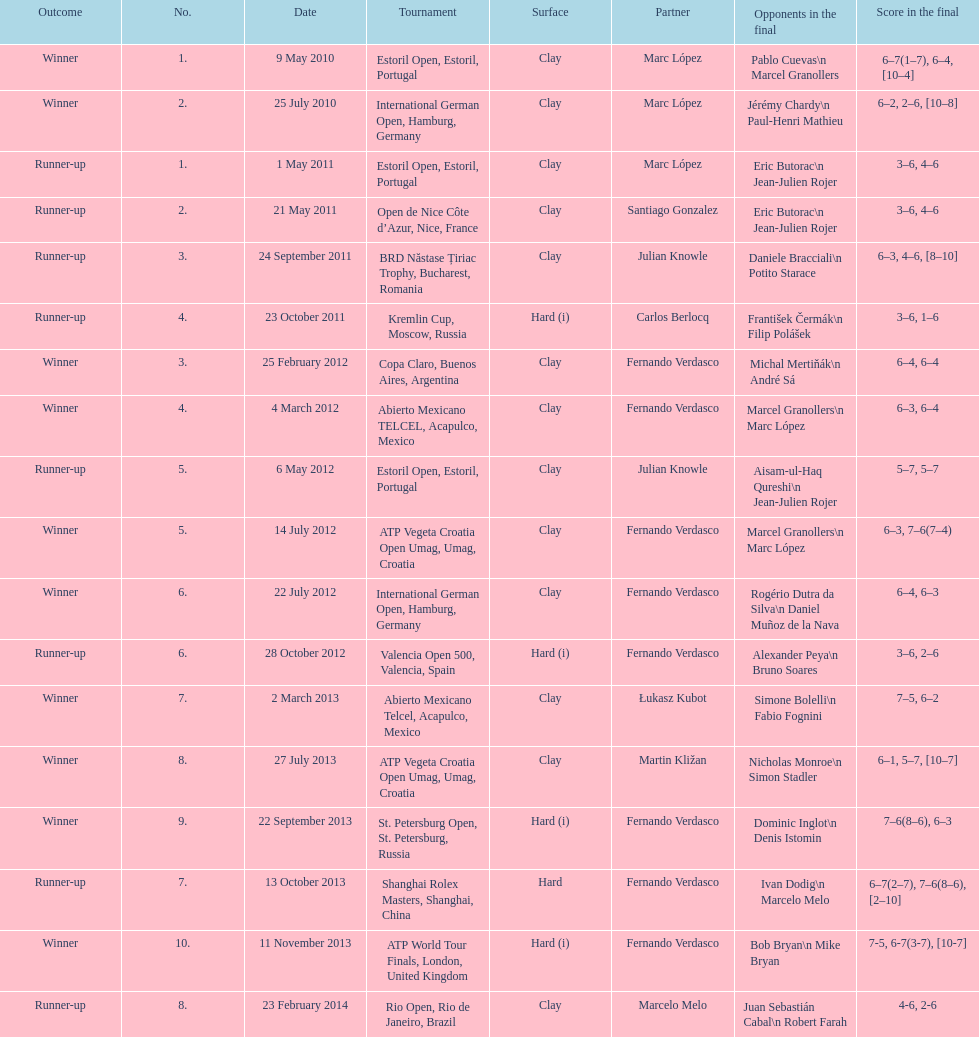How many runner-ups at most are listed? 8. 